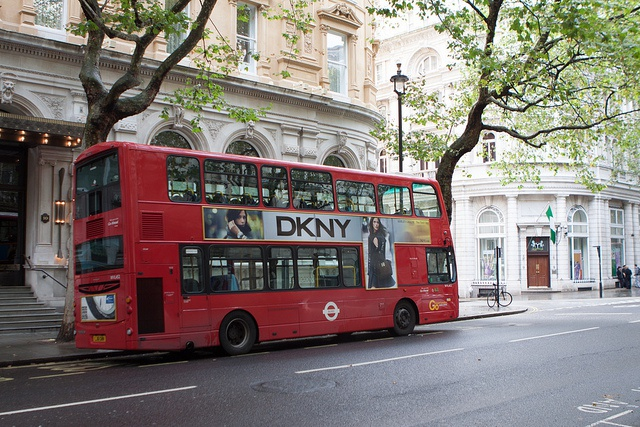Describe the objects in this image and their specific colors. I can see bus in tan, black, maroon, brown, and gray tones, bicycle in tan, lightgray, darkgray, gray, and black tones, people in tan, black, navy, gray, and blue tones, people in tan, darkgray, and gray tones, and people in tan, black, blue, and gray tones in this image. 